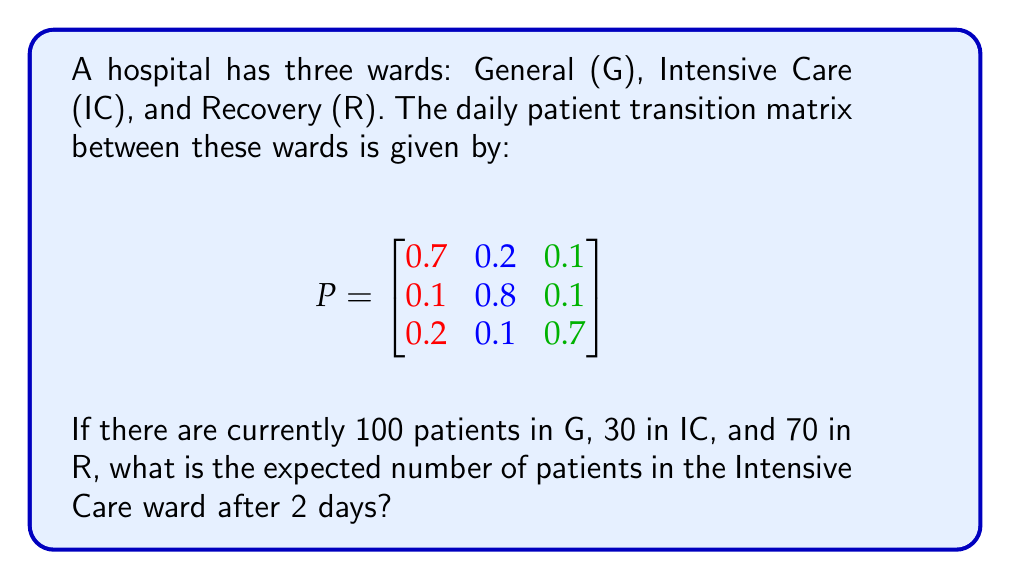Help me with this question. Let's approach this step-by-step:

1) First, we need to represent the current patient distribution as a vector:
   $$v_0 = \begin{bmatrix} 100 \\ 30 \\ 70 \end{bmatrix}$$

2) To find the distribution after 2 days, we need to multiply the transition matrix by itself and then by the initial distribution:
   $$v_2 = P^2 \cdot v_0$$

3) Let's calculate $P^2$:
   $$P^2 = P \cdot P = \begin{bmatrix}
   0.7 & 0.2 & 0.1 \\
   0.1 & 0.8 & 0.1 \\
   0.2 & 0.1 & 0.7
   \end{bmatrix} \cdot \begin{bmatrix}
   0.7 & 0.2 & 0.1 \\
   0.1 & 0.8 & 0.1 \\
   0.2 & 0.1 & 0.7
   \end{bmatrix}$$

4) Performing the matrix multiplication:
   $$P^2 = \begin{bmatrix}
   0.53 & 0.31 & 0.16 \\
   0.17 & 0.67 & 0.16 \\
   0.31 & 0.23 & 0.46
   \end{bmatrix}$$

5) Now, we multiply $P^2$ by $v_0$:
   $$v_2 = \begin{bmatrix}
   0.53 & 0.31 & 0.16 \\
   0.17 & 0.67 & 0.16 \\
   0.31 & 0.23 & 0.46
   \end{bmatrix} \cdot \begin{bmatrix} 100 \\ 30 \\ 70 \end{bmatrix}$$

6) Performing this multiplication:
   $$v_2 = \begin{bmatrix}
   53 + 9.3 + 11.2 \\
   17 + 20.1 + 11.2 \\
   31 + 6.9 + 32.2
   \end{bmatrix} = \begin{bmatrix}
   73.5 \\
   48.3 \\
   70.1
   \end{bmatrix}$$

7) The second element of this vector represents the expected number of patients in the Intensive Care ward after 2 days.
Answer: 48.3 patients 